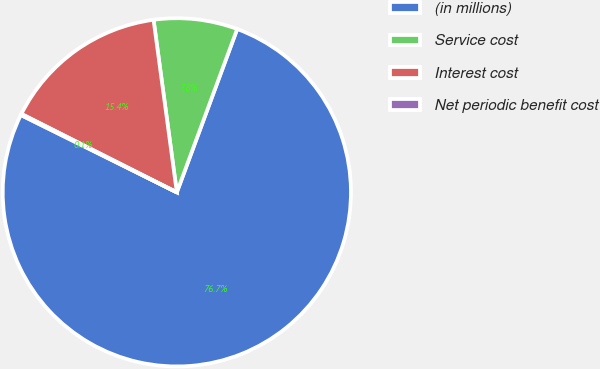Convert chart. <chart><loc_0><loc_0><loc_500><loc_500><pie_chart><fcel>(in millions)<fcel>Service cost<fcel>Interest cost<fcel>Net periodic benefit cost<nl><fcel>76.69%<fcel>7.77%<fcel>15.43%<fcel>0.11%<nl></chart> 